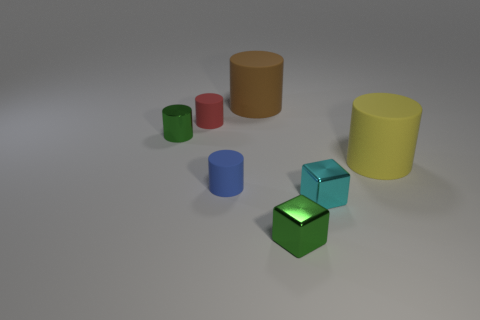What material is the green cylinder that is the same size as the red rubber cylinder?
Your answer should be compact. Metal. Are there more small rubber objects that are in front of the yellow rubber thing than large yellow rubber objects in front of the blue rubber thing?
Provide a succinct answer. Yes. Is there a cyan thing of the same shape as the blue thing?
Provide a short and direct response. No. There is a cyan thing that is the same size as the green metallic cube; what is its shape?
Keep it short and to the point. Cube. What is the shape of the matte object that is to the right of the cyan cube?
Give a very brief answer. Cylinder. Are there fewer rubber things that are to the right of the small blue rubber thing than matte cylinders that are left of the yellow rubber object?
Give a very brief answer. Yes. Does the green cylinder have the same size as the cylinder that is to the right of the cyan object?
Provide a short and direct response. No. What number of shiny cubes have the same size as the shiny cylinder?
Keep it short and to the point. 2. What is the color of the cylinder that is the same material as the tiny cyan object?
Provide a short and direct response. Green. Are there more green cubes than cyan spheres?
Your answer should be very brief. Yes. 